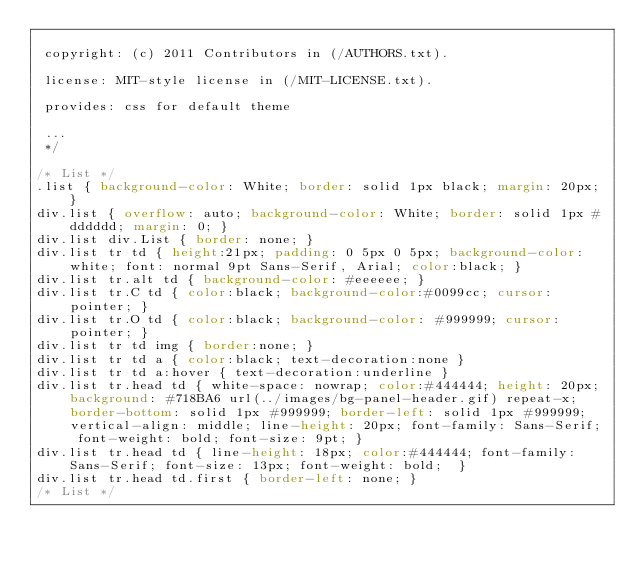Convert code to text. <code><loc_0><loc_0><loc_500><loc_500><_CSS_>
 copyright: (c) 2011 Contributors in (/AUTHORS.txt).

 license: MIT-style license in (/MIT-LICENSE.txt).

 provides: css for default theme

 ...
 */

/* List */
.list { background-color: White; border: solid 1px black; margin: 20px; }
div.list { overflow: auto; background-color: White; border: solid 1px #dddddd; margin: 0; }
div.list div.List { border: none; }
div.list tr td { height:21px; padding: 0 5px 0 5px; background-color: white; font: normal 9pt Sans-Serif, Arial; color:black; }
div.list tr.alt td { background-color: #eeeeee; }
div.list tr.C td { color:black; background-color:#0099cc; cursor: pointer; }
div.list tr.O td { color:black; background-color: #999999; cursor: pointer; }
div.list tr td img { border:none; }
div.list tr td a { color:black; text-decoration:none }
div.list tr td a:hover { text-decoration:underline }
div.list tr.head td { white-space: nowrap; color:#444444; height: 20px; background: #718BA6 url(../images/bg-panel-header.gif) repeat-x; border-bottom: solid 1px #999999; border-left: solid 1px #999999; vertical-align: middle; line-height: 20px; font-family: Sans-Serif; font-weight: bold; font-size: 9pt; }
div.list tr.head td { line-height: 18px; color:#444444; font-family: Sans-Serif; font-size: 13px; font-weight: bold;  }
div.list tr.head td.first { border-left: none; }
/* List */</code> 